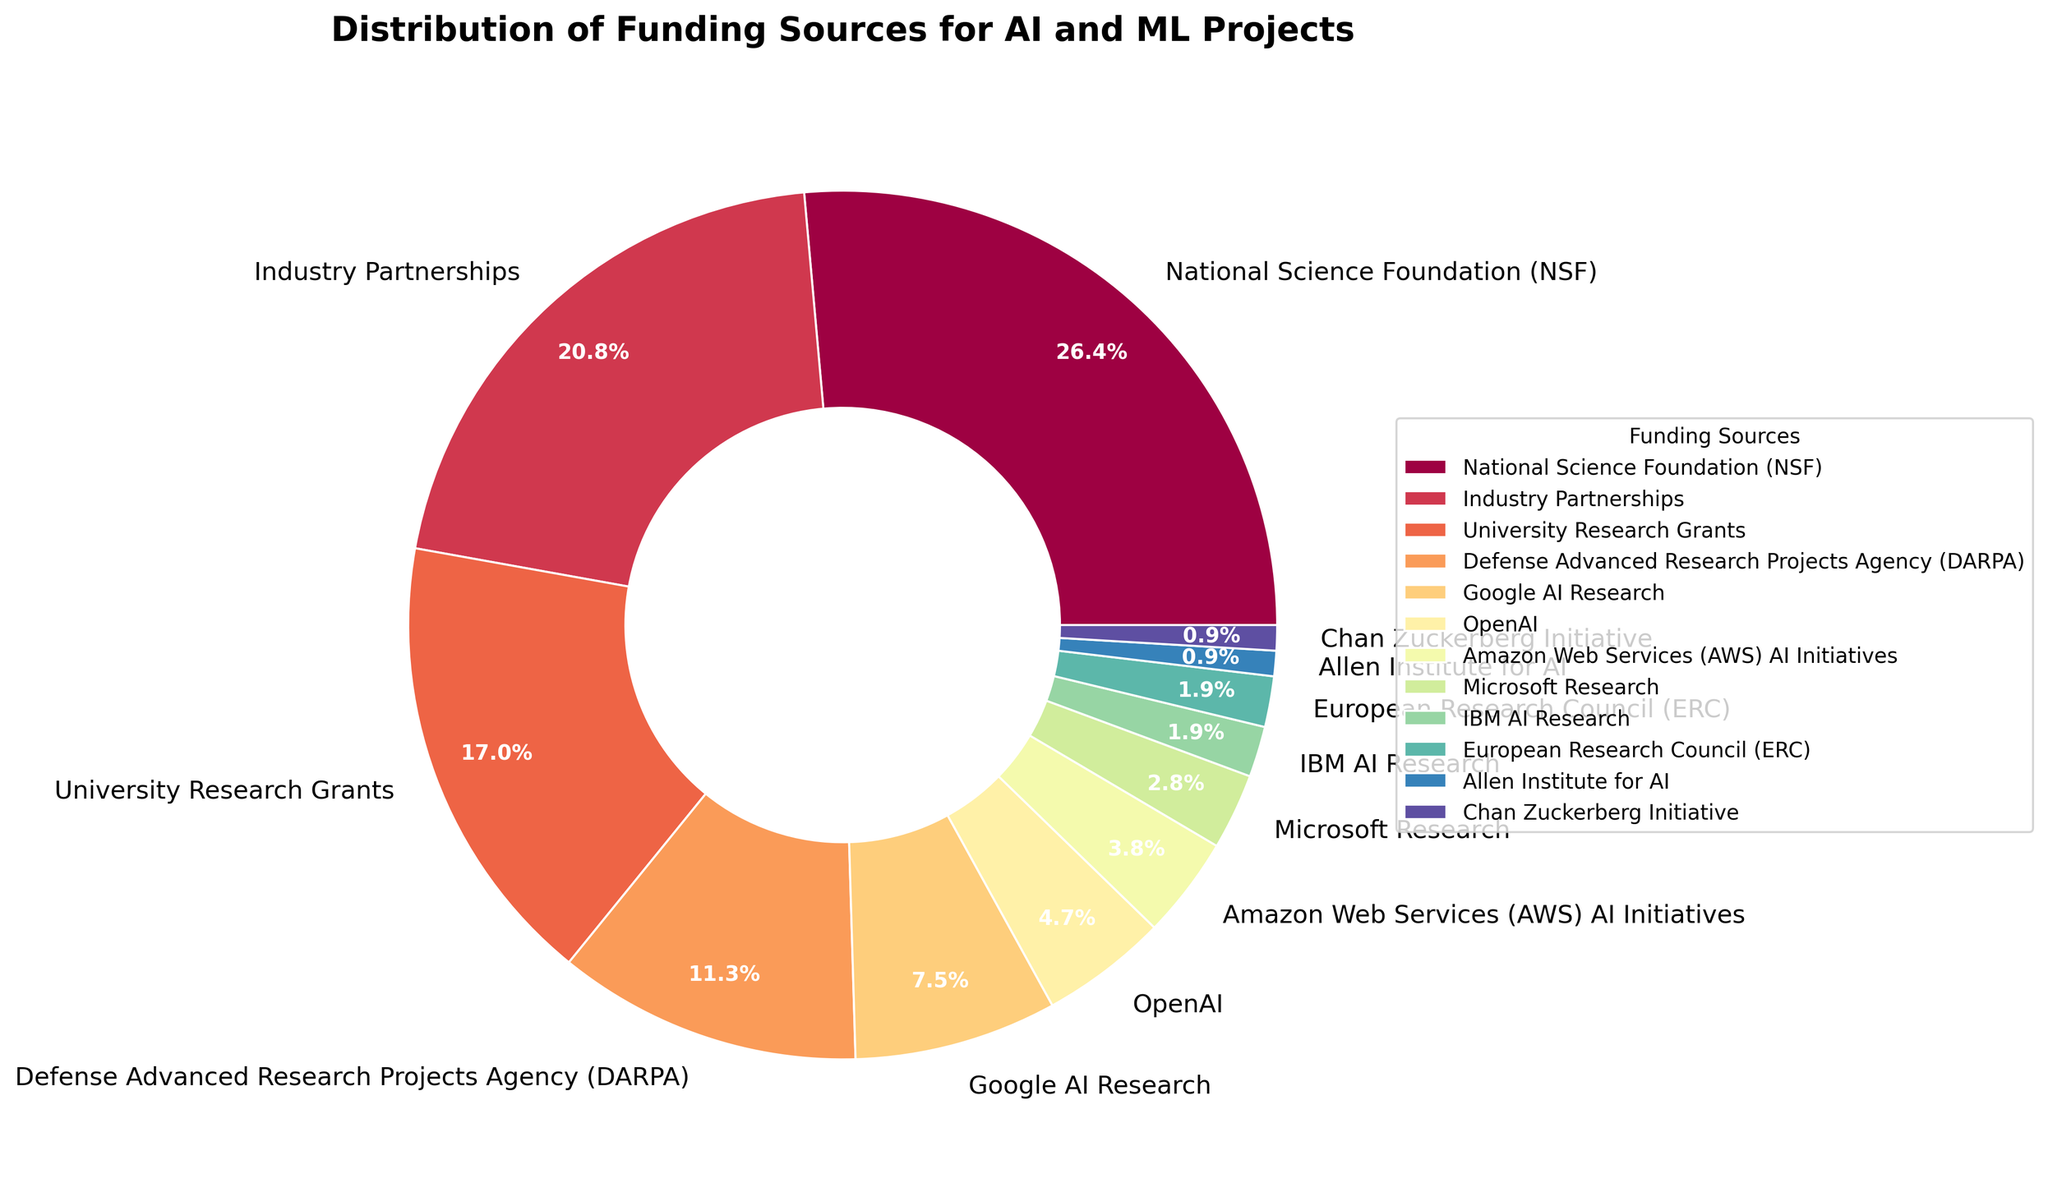What percentage of the funding is provided by the National Science Foundation (NSF)? From the pie chart, find the section labeled "National Science Foundation (NSF)" and note the percentage figure displayed with it.
Answer: 28% What is the combined funding percentage from Google AI Research, OpenAI, and Amazon Web Services (AWS) AI Initiatives? Locate the segments for Google AI Research (8%), OpenAI (5%), and Amazon Web Services (AWS) AI Initiatives (4%) in the pie chart and add their percentages. Thus, 8% + 5% + 4% = 17%.
Answer: 17% Which funding source provides a smaller percentage, Allen Institute for AI or Chan Zuckerberg Initiative? Compare the percentages next to "Allen Institute for AI" (1%) and "Chan Zuckerberg Initiative" (1%). Since they are equal, the answer is both.
Answer: Both What is the difference in funding percentages between Industry Partnerships and DARPA? Locate "Industry Partnerships" (22%) and "DARPA" (12%) in the pie chart, then compute the difference: 22% - 12% = 10%.
Answer: 10% Is the funding from University Research Grants greater than or less than the combined funding from Microsoft Research and IBM AI Research? Find the percentages for University Research Grants (18%), Microsoft Research (3%), and IBM AI Research (2%). Calculate combined funding for Microsoft Research and IBM AI Research: 3% + 2% = 5%. Compare 18% and 5%. 18% is greater.
Answer: Greater What is the total percentage of funding provided by all non-governmental sources (industry partnerships, private companies, and initiatives)? Identify the percentages from non-governmental sources: Industry Partnerships (22%), Google AI Research (8%), OpenAI (5%), Amazon Web Services (AWS) AI Initiatives (4%), Microsoft Research (3%), IBM AI Research (2%), Allen Institute for AI (1%), and Chan Zuckerberg Initiative (1%). Sum these up: 22% + 8% + 5% + 4% + 3% + 2% + 1% + 1% = 46%.
Answer: 46% Which funding source has the smallest segment in the pie chart? Identify the smallest percentage value from the chart, which is 1%, associated with both Allen Institute for AI and Chan Zuckerberg Initiative. Thus, both have the smallest segment.
Answer: Allen Institute for AI, Chan Zuckerberg Initiative 